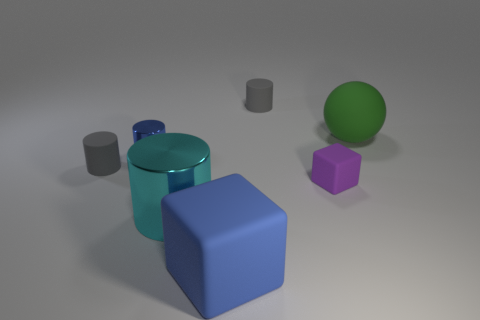Subtract all cyan cylinders. How many cylinders are left? 3 Add 1 small blue shiny objects. How many objects exist? 8 Subtract all brown cubes. How many gray cylinders are left? 2 Subtract all gray cylinders. How many cylinders are left? 2 Subtract 1 blocks. How many blocks are left? 1 Subtract all cylinders. How many objects are left? 3 Add 6 green matte objects. How many green matte objects are left? 7 Add 4 large things. How many large things exist? 7 Subtract 0 purple balls. How many objects are left? 7 Subtract all red cylinders. Subtract all cyan cubes. How many cylinders are left? 4 